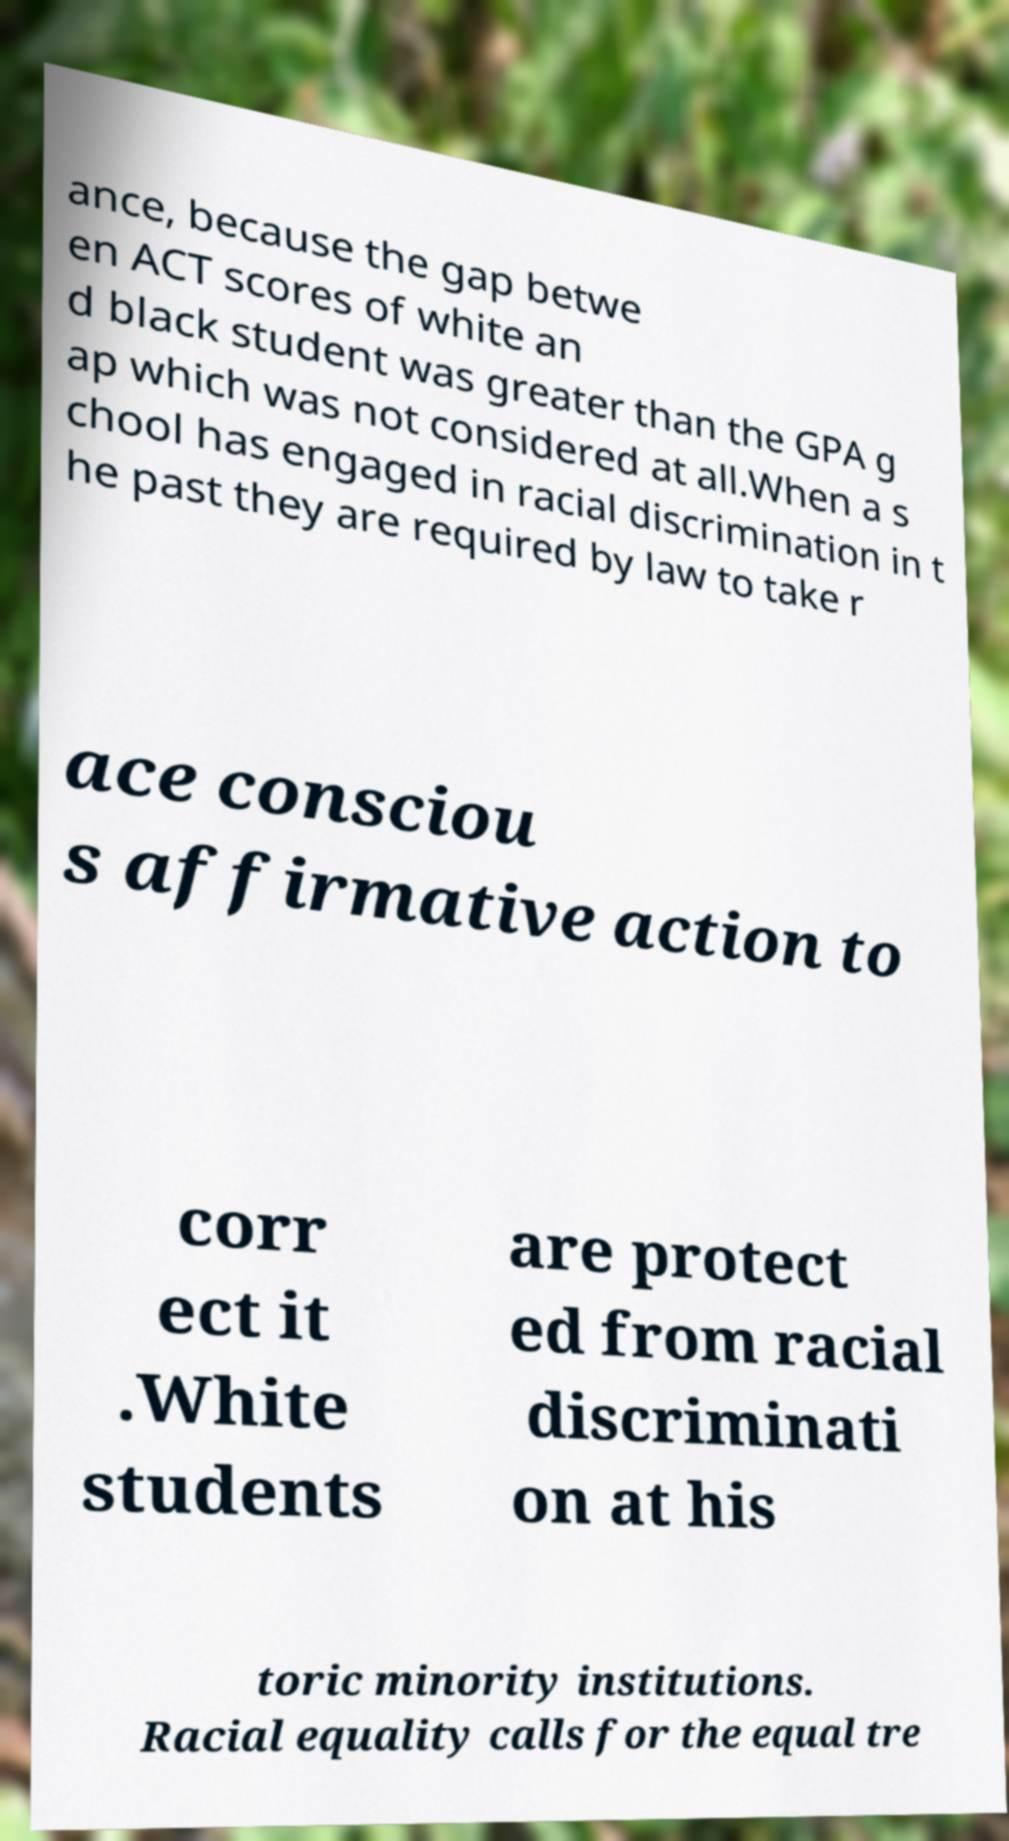For documentation purposes, I need the text within this image transcribed. Could you provide that? ance, because the gap betwe en ACT scores of white an d black student was greater than the GPA g ap which was not considered at all.When a s chool has engaged in racial discrimination in t he past they are required by law to take r ace consciou s affirmative action to corr ect it .White students are protect ed from racial discriminati on at his toric minority institutions. Racial equality calls for the equal tre 